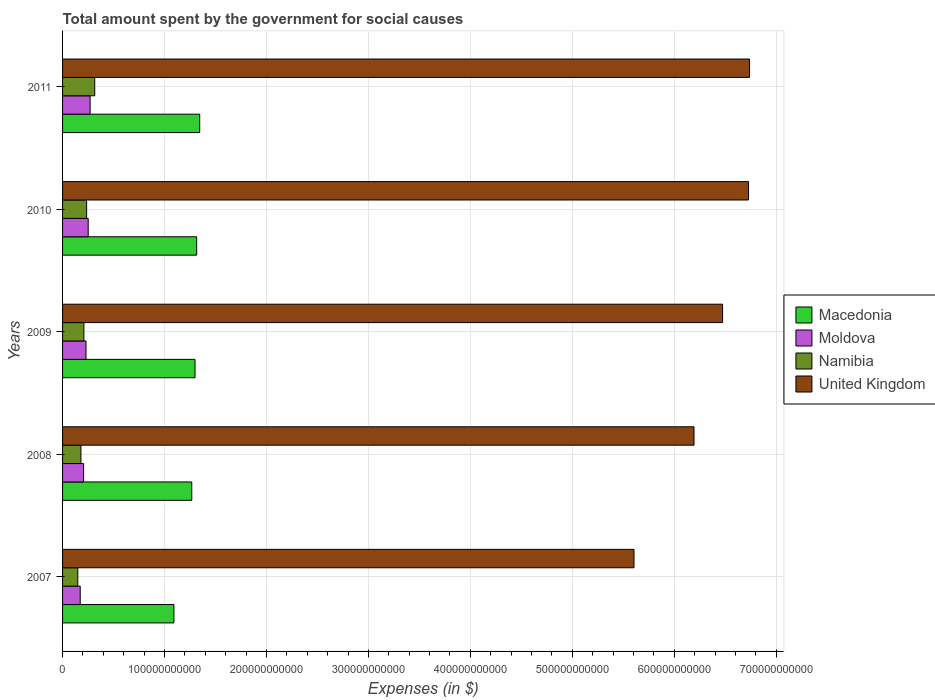How many bars are there on the 4th tick from the top?
Offer a very short reply. 4. How many bars are there on the 2nd tick from the bottom?
Your answer should be compact. 4. What is the label of the 2nd group of bars from the top?
Offer a very short reply. 2010. What is the amount spent for social causes by the government in Namibia in 2010?
Your answer should be very brief. 2.36e+1. Across all years, what is the maximum amount spent for social causes by the government in Namibia?
Give a very brief answer. 3.16e+1. Across all years, what is the minimum amount spent for social causes by the government in Moldova?
Make the answer very short. 1.73e+1. In which year was the amount spent for social causes by the government in Namibia maximum?
Offer a terse response. 2011. What is the total amount spent for social causes by the government in Namibia in the graph?
Your answer should be very brief. 1.09e+11. What is the difference between the amount spent for social causes by the government in Namibia in 2007 and that in 2008?
Provide a short and direct response. -3.08e+09. What is the difference between the amount spent for social causes by the government in Macedonia in 2009 and the amount spent for social causes by the government in United Kingdom in 2008?
Give a very brief answer. -4.89e+11. What is the average amount spent for social causes by the government in Moldova per year?
Provide a short and direct response. 2.26e+1. In the year 2009, what is the difference between the amount spent for social causes by the government in Namibia and amount spent for social causes by the government in United Kingdom?
Your answer should be compact. -6.27e+11. In how many years, is the amount spent for social causes by the government in Moldova greater than 140000000000 $?
Make the answer very short. 0. What is the ratio of the amount spent for social causes by the government in Moldova in 2007 to that in 2008?
Provide a short and direct response. 0.84. Is the difference between the amount spent for social causes by the government in Namibia in 2007 and 2008 greater than the difference between the amount spent for social causes by the government in United Kingdom in 2007 and 2008?
Offer a very short reply. Yes. What is the difference between the highest and the second highest amount spent for social causes by the government in Namibia?
Offer a terse response. 7.94e+09. What is the difference between the highest and the lowest amount spent for social causes by the government in Macedonia?
Ensure brevity in your answer.  2.53e+1. Is the sum of the amount spent for social causes by the government in Moldova in 2008 and 2011 greater than the maximum amount spent for social causes by the government in Macedonia across all years?
Your answer should be compact. No. Is it the case that in every year, the sum of the amount spent for social causes by the government in Macedonia and amount spent for social causes by the government in Namibia is greater than the sum of amount spent for social causes by the government in Moldova and amount spent for social causes by the government in United Kingdom?
Keep it short and to the point. No. What does the 4th bar from the top in 2007 represents?
Your answer should be very brief. Macedonia. What does the 1st bar from the bottom in 2009 represents?
Your answer should be compact. Macedonia. Are all the bars in the graph horizontal?
Ensure brevity in your answer.  Yes. How many years are there in the graph?
Your answer should be very brief. 5. What is the difference between two consecutive major ticks on the X-axis?
Your answer should be compact. 1.00e+11. Are the values on the major ticks of X-axis written in scientific E-notation?
Keep it short and to the point. No. Does the graph contain any zero values?
Your answer should be very brief. No. Does the graph contain grids?
Offer a terse response. Yes. How many legend labels are there?
Your answer should be compact. 4. How are the legend labels stacked?
Give a very brief answer. Vertical. What is the title of the graph?
Ensure brevity in your answer.  Total amount spent by the government for social causes. What is the label or title of the X-axis?
Make the answer very short. Expenses (in $). What is the Expenses (in $) in Macedonia in 2007?
Make the answer very short. 1.09e+11. What is the Expenses (in $) of Moldova in 2007?
Your response must be concise. 1.73e+1. What is the Expenses (in $) in Namibia in 2007?
Keep it short and to the point. 1.49e+1. What is the Expenses (in $) of United Kingdom in 2007?
Provide a succinct answer. 5.61e+11. What is the Expenses (in $) of Macedonia in 2008?
Your answer should be very brief. 1.27e+11. What is the Expenses (in $) of Moldova in 2008?
Your response must be concise. 2.06e+1. What is the Expenses (in $) of Namibia in 2008?
Offer a terse response. 1.80e+1. What is the Expenses (in $) of United Kingdom in 2008?
Keep it short and to the point. 6.19e+11. What is the Expenses (in $) in Macedonia in 2009?
Ensure brevity in your answer.  1.30e+11. What is the Expenses (in $) of Moldova in 2009?
Give a very brief answer. 2.30e+1. What is the Expenses (in $) in Namibia in 2009?
Offer a terse response. 2.09e+1. What is the Expenses (in $) of United Kingdom in 2009?
Your answer should be compact. 6.47e+11. What is the Expenses (in $) of Macedonia in 2010?
Give a very brief answer. 1.32e+11. What is the Expenses (in $) of Moldova in 2010?
Provide a succinct answer. 2.51e+1. What is the Expenses (in $) in Namibia in 2010?
Make the answer very short. 2.36e+1. What is the Expenses (in $) in United Kingdom in 2010?
Your response must be concise. 6.73e+11. What is the Expenses (in $) in Macedonia in 2011?
Your answer should be compact. 1.35e+11. What is the Expenses (in $) in Moldova in 2011?
Keep it short and to the point. 2.70e+1. What is the Expenses (in $) in Namibia in 2011?
Your answer should be compact. 3.16e+1. What is the Expenses (in $) in United Kingdom in 2011?
Keep it short and to the point. 6.74e+11. Across all years, what is the maximum Expenses (in $) of Macedonia?
Keep it short and to the point. 1.35e+11. Across all years, what is the maximum Expenses (in $) in Moldova?
Provide a succinct answer. 2.70e+1. Across all years, what is the maximum Expenses (in $) in Namibia?
Keep it short and to the point. 3.16e+1. Across all years, what is the maximum Expenses (in $) of United Kingdom?
Your answer should be very brief. 6.74e+11. Across all years, what is the minimum Expenses (in $) of Macedonia?
Ensure brevity in your answer.  1.09e+11. Across all years, what is the minimum Expenses (in $) of Moldova?
Your answer should be compact. 1.73e+1. Across all years, what is the minimum Expenses (in $) in Namibia?
Offer a very short reply. 1.49e+1. Across all years, what is the minimum Expenses (in $) of United Kingdom?
Your answer should be compact. 5.61e+11. What is the total Expenses (in $) in Macedonia in the graph?
Your answer should be compact. 6.32e+11. What is the total Expenses (in $) in Moldova in the graph?
Your answer should be very brief. 1.13e+11. What is the total Expenses (in $) of Namibia in the graph?
Ensure brevity in your answer.  1.09e+11. What is the total Expenses (in $) of United Kingdom in the graph?
Keep it short and to the point. 3.17e+12. What is the difference between the Expenses (in $) in Macedonia in 2007 and that in 2008?
Offer a terse response. -1.75e+1. What is the difference between the Expenses (in $) in Moldova in 2007 and that in 2008?
Provide a succinct answer. -3.31e+09. What is the difference between the Expenses (in $) of Namibia in 2007 and that in 2008?
Provide a succinct answer. -3.08e+09. What is the difference between the Expenses (in $) of United Kingdom in 2007 and that in 2008?
Ensure brevity in your answer.  -5.89e+1. What is the difference between the Expenses (in $) of Macedonia in 2007 and that in 2009?
Your answer should be compact. -2.07e+1. What is the difference between the Expenses (in $) of Moldova in 2007 and that in 2009?
Your answer should be compact. -5.67e+09. What is the difference between the Expenses (in $) in Namibia in 2007 and that in 2009?
Provide a short and direct response. -5.99e+09. What is the difference between the Expenses (in $) in United Kingdom in 2007 and that in 2009?
Your answer should be compact. -8.69e+1. What is the difference between the Expenses (in $) in Macedonia in 2007 and that in 2010?
Your response must be concise. -2.23e+1. What is the difference between the Expenses (in $) in Moldova in 2007 and that in 2010?
Provide a short and direct response. -7.83e+09. What is the difference between the Expenses (in $) in Namibia in 2007 and that in 2010?
Keep it short and to the point. -8.67e+09. What is the difference between the Expenses (in $) in United Kingdom in 2007 and that in 2010?
Your answer should be very brief. -1.12e+11. What is the difference between the Expenses (in $) of Macedonia in 2007 and that in 2011?
Make the answer very short. -2.53e+1. What is the difference between the Expenses (in $) of Moldova in 2007 and that in 2011?
Provide a succinct answer. -9.71e+09. What is the difference between the Expenses (in $) in Namibia in 2007 and that in 2011?
Your answer should be very brief. -1.66e+1. What is the difference between the Expenses (in $) in United Kingdom in 2007 and that in 2011?
Provide a succinct answer. -1.13e+11. What is the difference between the Expenses (in $) in Macedonia in 2008 and that in 2009?
Offer a terse response. -3.19e+09. What is the difference between the Expenses (in $) of Moldova in 2008 and that in 2009?
Your answer should be compact. -2.36e+09. What is the difference between the Expenses (in $) in Namibia in 2008 and that in 2009?
Offer a terse response. -2.91e+09. What is the difference between the Expenses (in $) in United Kingdom in 2008 and that in 2009?
Your answer should be very brief. -2.80e+1. What is the difference between the Expenses (in $) in Macedonia in 2008 and that in 2010?
Ensure brevity in your answer.  -4.81e+09. What is the difference between the Expenses (in $) in Moldova in 2008 and that in 2010?
Provide a short and direct response. -4.52e+09. What is the difference between the Expenses (in $) in Namibia in 2008 and that in 2010?
Offer a very short reply. -5.59e+09. What is the difference between the Expenses (in $) of United Kingdom in 2008 and that in 2010?
Your answer should be very brief. -5.35e+1. What is the difference between the Expenses (in $) in Macedonia in 2008 and that in 2011?
Provide a short and direct response. -7.78e+09. What is the difference between the Expenses (in $) of Moldova in 2008 and that in 2011?
Make the answer very short. -6.40e+09. What is the difference between the Expenses (in $) in Namibia in 2008 and that in 2011?
Provide a succinct answer. -1.35e+1. What is the difference between the Expenses (in $) in United Kingdom in 2008 and that in 2011?
Offer a terse response. -5.45e+1. What is the difference between the Expenses (in $) of Macedonia in 2009 and that in 2010?
Keep it short and to the point. -1.62e+09. What is the difference between the Expenses (in $) of Moldova in 2009 and that in 2010?
Your answer should be very brief. -2.16e+09. What is the difference between the Expenses (in $) of Namibia in 2009 and that in 2010?
Ensure brevity in your answer.  -2.68e+09. What is the difference between the Expenses (in $) of United Kingdom in 2009 and that in 2010?
Provide a succinct answer. -2.55e+1. What is the difference between the Expenses (in $) in Macedonia in 2009 and that in 2011?
Ensure brevity in your answer.  -4.59e+09. What is the difference between the Expenses (in $) in Moldova in 2009 and that in 2011?
Keep it short and to the point. -4.04e+09. What is the difference between the Expenses (in $) in Namibia in 2009 and that in 2011?
Keep it short and to the point. -1.06e+1. What is the difference between the Expenses (in $) in United Kingdom in 2009 and that in 2011?
Ensure brevity in your answer.  -2.65e+1. What is the difference between the Expenses (in $) in Macedonia in 2010 and that in 2011?
Your answer should be very brief. -2.96e+09. What is the difference between the Expenses (in $) in Moldova in 2010 and that in 2011?
Give a very brief answer. -1.88e+09. What is the difference between the Expenses (in $) of Namibia in 2010 and that in 2011?
Your response must be concise. -7.94e+09. What is the difference between the Expenses (in $) of United Kingdom in 2010 and that in 2011?
Your answer should be compact. -1.00e+09. What is the difference between the Expenses (in $) in Macedonia in 2007 and the Expenses (in $) in Moldova in 2008?
Your response must be concise. 8.86e+1. What is the difference between the Expenses (in $) of Macedonia in 2007 and the Expenses (in $) of Namibia in 2008?
Your response must be concise. 9.12e+1. What is the difference between the Expenses (in $) in Macedonia in 2007 and the Expenses (in $) in United Kingdom in 2008?
Make the answer very short. -5.10e+11. What is the difference between the Expenses (in $) of Moldova in 2007 and the Expenses (in $) of Namibia in 2008?
Provide a succinct answer. -7.04e+08. What is the difference between the Expenses (in $) in Moldova in 2007 and the Expenses (in $) in United Kingdom in 2008?
Keep it short and to the point. -6.02e+11. What is the difference between the Expenses (in $) of Namibia in 2007 and the Expenses (in $) of United Kingdom in 2008?
Offer a very short reply. -6.04e+11. What is the difference between the Expenses (in $) in Macedonia in 2007 and the Expenses (in $) in Moldova in 2009?
Ensure brevity in your answer.  8.63e+1. What is the difference between the Expenses (in $) of Macedonia in 2007 and the Expenses (in $) of Namibia in 2009?
Offer a terse response. 8.83e+1. What is the difference between the Expenses (in $) in Macedonia in 2007 and the Expenses (in $) in United Kingdom in 2009?
Offer a terse response. -5.38e+11. What is the difference between the Expenses (in $) in Moldova in 2007 and the Expenses (in $) in Namibia in 2009?
Your answer should be very brief. -3.61e+09. What is the difference between the Expenses (in $) in Moldova in 2007 and the Expenses (in $) in United Kingdom in 2009?
Ensure brevity in your answer.  -6.30e+11. What is the difference between the Expenses (in $) of Namibia in 2007 and the Expenses (in $) of United Kingdom in 2009?
Keep it short and to the point. -6.33e+11. What is the difference between the Expenses (in $) of Macedonia in 2007 and the Expenses (in $) of Moldova in 2010?
Your answer should be very brief. 8.41e+1. What is the difference between the Expenses (in $) of Macedonia in 2007 and the Expenses (in $) of Namibia in 2010?
Give a very brief answer. 8.56e+1. What is the difference between the Expenses (in $) of Macedonia in 2007 and the Expenses (in $) of United Kingdom in 2010?
Ensure brevity in your answer.  -5.64e+11. What is the difference between the Expenses (in $) in Moldova in 2007 and the Expenses (in $) in Namibia in 2010?
Offer a terse response. -6.29e+09. What is the difference between the Expenses (in $) of Moldova in 2007 and the Expenses (in $) of United Kingdom in 2010?
Provide a succinct answer. -6.56e+11. What is the difference between the Expenses (in $) of Namibia in 2007 and the Expenses (in $) of United Kingdom in 2010?
Make the answer very short. -6.58e+11. What is the difference between the Expenses (in $) of Macedonia in 2007 and the Expenses (in $) of Moldova in 2011?
Provide a short and direct response. 8.22e+1. What is the difference between the Expenses (in $) of Macedonia in 2007 and the Expenses (in $) of Namibia in 2011?
Provide a short and direct response. 7.77e+1. What is the difference between the Expenses (in $) in Macedonia in 2007 and the Expenses (in $) in United Kingdom in 2011?
Offer a terse response. -5.65e+11. What is the difference between the Expenses (in $) of Moldova in 2007 and the Expenses (in $) of Namibia in 2011?
Offer a terse response. -1.42e+1. What is the difference between the Expenses (in $) of Moldova in 2007 and the Expenses (in $) of United Kingdom in 2011?
Your response must be concise. -6.57e+11. What is the difference between the Expenses (in $) in Namibia in 2007 and the Expenses (in $) in United Kingdom in 2011?
Provide a short and direct response. -6.59e+11. What is the difference between the Expenses (in $) in Macedonia in 2008 and the Expenses (in $) in Moldova in 2009?
Offer a terse response. 1.04e+11. What is the difference between the Expenses (in $) in Macedonia in 2008 and the Expenses (in $) in Namibia in 2009?
Your answer should be compact. 1.06e+11. What is the difference between the Expenses (in $) of Macedonia in 2008 and the Expenses (in $) of United Kingdom in 2009?
Offer a very short reply. -5.21e+11. What is the difference between the Expenses (in $) of Moldova in 2008 and the Expenses (in $) of Namibia in 2009?
Make the answer very short. -3.03e+08. What is the difference between the Expenses (in $) in Moldova in 2008 and the Expenses (in $) in United Kingdom in 2009?
Offer a very short reply. -6.27e+11. What is the difference between the Expenses (in $) of Namibia in 2008 and the Expenses (in $) of United Kingdom in 2009?
Provide a succinct answer. -6.29e+11. What is the difference between the Expenses (in $) of Macedonia in 2008 and the Expenses (in $) of Moldova in 2010?
Ensure brevity in your answer.  1.02e+11. What is the difference between the Expenses (in $) of Macedonia in 2008 and the Expenses (in $) of Namibia in 2010?
Make the answer very short. 1.03e+11. What is the difference between the Expenses (in $) in Macedonia in 2008 and the Expenses (in $) in United Kingdom in 2010?
Keep it short and to the point. -5.46e+11. What is the difference between the Expenses (in $) in Moldova in 2008 and the Expenses (in $) in Namibia in 2010?
Keep it short and to the point. -2.98e+09. What is the difference between the Expenses (in $) in Moldova in 2008 and the Expenses (in $) in United Kingdom in 2010?
Provide a succinct answer. -6.52e+11. What is the difference between the Expenses (in $) of Namibia in 2008 and the Expenses (in $) of United Kingdom in 2010?
Offer a very short reply. -6.55e+11. What is the difference between the Expenses (in $) of Macedonia in 2008 and the Expenses (in $) of Moldova in 2011?
Ensure brevity in your answer.  9.97e+1. What is the difference between the Expenses (in $) of Macedonia in 2008 and the Expenses (in $) of Namibia in 2011?
Offer a terse response. 9.52e+1. What is the difference between the Expenses (in $) in Macedonia in 2008 and the Expenses (in $) in United Kingdom in 2011?
Keep it short and to the point. -5.47e+11. What is the difference between the Expenses (in $) of Moldova in 2008 and the Expenses (in $) of Namibia in 2011?
Give a very brief answer. -1.09e+1. What is the difference between the Expenses (in $) of Moldova in 2008 and the Expenses (in $) of United Kingdom in 2011?
Provide a short and direct response. -6.53e+11. What is the difference between the Expenses (in $) of Namibia in 2008 and the Expenses (in $) of United Kingdom in 2011?
Ensure brevity in your answer.  -6.56e+11. What is the difference between the Expenses (in $) of Macedonia in 2009 and the Expenses (in $) of Moldova in 2010?
Make the answer very short. 1.05e+11. What is the difference between the Expenses (in $) of Macedonia in 2009 and the Expenses (in $) of Namibia in 2010?
Offer a very short reply. 1.06e+11. What is the difference between the Expenses (in $) in Macedonia in 2009 and the Expenses (in $) in United Kingdom in 2010?
Provide a short and direct response. -5.43e+11. What is the difference between the Expenses (in $) of Moldova in 2009 and the Expenses (in $) of Namibia in 2010?
Offer a terse response. -6.19e+08. What is the difference between the Expenses (in $) of Moldova in 2009 and the Expenses (in $) of United Kingdom in 2010?
Give a very brief answer. -6.50e+11. What is the difference between the Expenses (in $) of Namibia in 2009 and the Expenses (in $) of United Kingdom in 2010?
Your response must be concise. -6.52e+11. What is the difference between the Expenses (in $) of Macedonia in 2009 and the Expenses (in $) of Moldova in 2011?
Offer a terse response. 1.03e+11. What is the difference between the Expenses (in $) of Macedonia in 2009 and the Expenses (in $) of Namibia in 2011?
Your answer should be compact. 9.84e+1. What is the difference between the Expenses (in $) in Macedonia in 2009 and the Expenses (in $) in United Kingdom in 2011?
Your response must be concise. -5.44e+11. What is the difference between the Expenses (in $) of Moldova in 2009 and the Expenses (in $) of Namibia in 2011?
Provide a short and direct response. -8.56e+09. What is the difference between the Expenses (in $) in Moldova in 2009 and the Expenses (in $) in United Kingdom in 2011?
Offer a very short reply. -6.51e+11. What is the difference between the Expenses (in $) of Namibia in 2009 and the Expenses (in $) of United Kingdom in 2011?
Make the answer very short. -6.53e+11. What is the difference between the Expenses (in $) of Macedonia in 2010 and the Expenses (in $) of Moldova in 2011?
Ensure brevity in your answer.  1.05e+11. What is the difference between the Expenses (in $) of Macedonia in 2010 and the Expenses (in $) of Namibia in 2011?
Provide a succinct answer. 1.00e+11. What is the difference between the Expenses (in $) in Macedonia in 2010 and the Expenses (in $) in United Kingdom in 2011?
Ensure brevity in your answer.  -5.42e+11. What is the difference between the Expenses (in $) of Moldova in 2010 and the Expenses (in $) of Namibia in 2011?
Your answer should be compact. -6.41e+09. What is the difference between the Expenses (in $) of Moldova in 2010 and the Expenses (in $) of United Kingdom in 2011?
Ensure brevity in your answer.  -6.49e+11. What is the difference between the Expenses (in $) in Namibia in 2010 and the Expenses (in $) in United Kingdom in 2011?
Keep it short and to the point. -6.50e+11. What is the average Expenses (in $) of Macedonia per year?
Ensure brevity in your answer.  1.26e+11. What is the average Expenses (in $) in Moldova per year?
Offer a very short reply. 2.26e+1. What is the average Expenses (in $) in Namibia per year?
Offer a terse response. 2.18e+1. What is the average Expenses (in $) of United Kingdom per year?
Provide a succinct answer. 6.35e+11. In the year 2007, what is the difference between the Expenses (in $) in Macedonia and Expenses (in $) in Moldova?
Offer a very short reply. 9.19e+1. In the year 2007, what is the difference between the Expenses (in $) of Macedonia and Expenses (in $) of Namibia?
Provide a short and direct response. 9.43e+1. In the year 2007, what is the difference between the Expenses (in $) in Macedonia and Expenses (in $) in United Kingdom?
Your answer should be very brief. -4.51e+11. In the year 2007, what is the difference between the Expenses (in $) in Moldova and Expenses (in $) in Namibia?
Your answer should be compact. 2.38e+09. In the year 2007, what is the difference between the Expenses (in $) of Moldova and Expenses (in $) of United Kingdom?
Offer a terse response. -5.43e+11. In the year 2007, what is the difference between the Expenses (in $) in Namibia and Expenses (in $) in United Kingdom?
Offer a very short reply. -5.46e+11. In the year 2008, what is the difference between the Expenses (in $) in Macedonia and Expenses (in $) in Moldova?
Provide a short and direct response. 1.06e+11. In the year 2008, what is the difference between the Expenses (in $) in Macedonia and Expenses (in $) in Namibia?
Your answer should be very brief. 1.09e+11. In the year 2008, what is the difference between the Expenses (in $) in Macedonia and Expenses (in $) in United Kingdom?
Give a very brief answer. -4.93e+11. In the year 2008, what is the difference between the Expenses (in $) of Moldova and Expenses (in $) of Namibia?
Provide a succinct answer. 2.60e+09. In the year 2008, what is the difference between the Expenses (in $) of Moldova and Expenses (in $) of United Kingdom?
Provide a short and direct response. -5.99e+11. In the year 2008, what is the difference between the Expenses (in $) in Namibia and Expenses (in $) in United Kingdom?
Your answer should be compact. -6.01e+11. In the year 2009, what is the difference between the Expenses (in $) of Macedonia and Expenses (in $) of Moldova?
Keep it short and to the point. 1.07e+11. In the year 2009, what is the difference between the Expenses (in $) of Macedonia and Expenses (in $) of Namibia?
Keep it short and to the point. 1.09e+11. In the year 2009, what is the difference between the Expenses (in $) in Macedonia and Expenses (in $) in United Kingdom?
Provide a short and direct response. -5.18e+11. In the year 2009, what is the difference between the Expenses (in $) in Moldova and Expenses (in $) in Namibia?
Offer a terse response. 2.06e+09. In the year 2009, what is the difference between the Expenses (in $) in Moldova and Expenses (in $) in United Kingdom?
Provide a short and direct response. -6.24e+11. In the year 2009, what is the difference between the Expenses (in $) of Namibia and Expenses (in $) of United Kingdom?
Make the answer very short. -6.27e+11. In the year 2010, what is the difference between the Expenses (in $) of Macedonia and Expenses (in $) of Moldova?
Your response must be concise. 1.06e+11. In the year 2010, what is the difference between the Expenses (in $) of Macedonia and Expenses (in $) of Namibia?
Your answer should be very brief. 1.08e+11. In the year 2010, what is the difference between the Expenses (in $) of Macedonia and Expenses (in $) of United Kingdom?
Provide a short and direct response. -5.41e+11. In the year 2010, what is the difference between the Expenses (in $) in Moldova and Expenses (in $) in Namibia?
Your answer should be compact. 1.54e+09. In the year 2010, what is the difference between the Expenses (in $) in Moldova and Expenses (in $) in United Kingdom?
Provide a short and direct response. -6.48e+11. In the year 2010, what is the difference between the Expenses (in $) in Namibia and Expenses (in $) in United Kingdom?
Your answer should be compact. -6.49e+11. In the year 2011, what is the difference between the Expenses (in $) in Macedonia and Expenses (in $) in Moldova?
Ensure brevity in your answer.  1.08e+11. In the year 2011, what is the difference between the Expenses (in $) in Macedonia and Expenses (in $) in Namibia?
Ensure brevity in your answer.  1.03e+11. In the year 2011, what is the difference between the Expenses (in $) of Macedonia and Expenses (in $) of United Kingdom?
Make the answer very short. -5.39e+11. In the year 2011, what is the difference between the Expenses (in $) in Moldova and Expenses (in $) in Namibia?
Your answer should be very brief. -4.53e+09. In the year 2011, what is the difference between the Expenses (in $) of Moldova and Expenses (in $) of United Kingdom?
Your response must be concise. -6.47e+11. In the year 2011, what is the difference between the Expenses (in $) in Namibia and Expenses (in $) in United Kingdom?
Offer a terse response. -6.42e+11. What is the ratio of the Expenses (in $) in Macedonia in 2007 to that in 2008?
Ensure brevity in your answer.  0.86. What is the ratio of the Expenses (in $) of Moldova in 2007 to that in 2008?
Ensure brevity in your answer.  0.84. What is the ratio of the Expenses (in $) in Namibia in 2007 to that in 2008?
Your answer should be very brief. 0.83. What is the ratio of the Expenses (in $) in United Kingdom in 2007 to that in 2008?
Provide a succinct answer. 0.91. What is the ratio of the Expenses (in $) in Macedonia in 2007 to that in 2009?
Make the answer very short. 0.84. What is the ratio of the Expenses (in $) in Moldova in 2007 to that in 2009?
Ensure brevity in your answer.  0.75. What is the ratio of the Expenses (in $) of Namibia in 2007 to that in 2009?
Make the answer very short. 0.71. What is the ratio of the Expenses (in $) in United Kingdom in 2007 to that in 2009?
Your answer should be very brief. 0.87. What is the ratio of the Expenses (in $) of Macedonia in 2007 to that in 2010?
Your answer should be very brief. 0.83. What is the ratio of the Expenses (in $) in Moldova in 2007 to that in 2010?
Make the answer very short. 0.69. What is the ratio of the Expenses (in $) in Namibia in 2007 to that in 2010?
Offer a very short reply. 0.63. What is the ratio of the Expenses (in $) of United Kingdom in 2007 to that in 2010?
Your answer should be very brief. 0.83. What is the ratio of the Expenses (in $) of Macedonia in 2007 to that in 2011?
Give a very brief answer. 0.81. What is the ratio of the Expenses (in $) in Moldova in 2007 to that in 2011?
Your answer should be compact. 0.64. What is the ratio of the Expenses (in $) of Namibia in 2007 to that in 2011?
Your response must be concise. 0.47. What is the ratio of the Expenses (in $) of United Kingdom in 2007 to that in 2011?
Your answer should be very brief. 0.83. What is the ratio of the Expenses (in $) in Macedonia in 2008 to that in 2009?
Ensure brevity in your answer.  0.98. What is the ratio of the Expenses (in $) of Moldova in 2008 to that in 2009?
Ensure brevity in your answer.  0.9. What is the ratio of the Expenses (in $) of Namibia in 2008 to that in 2009?
Provide a succinct answer. 0.86. What is the ratio of the Expenses (in $) of United Kingdom in 2008 to that in 2009?
Provide a short and direct response. 0.96. What is the ratio of the Expenses (in $) of Macedonia in 2008 to that in 2010?
Keep it short and to the point. 0.96. What is the ratio of the Expenses (in $) of Moldova in 2008 to that in 2010?
Your answer should be very brief. 0.82. What is the ratio of the Expenses (in $) of Namibia in 2008 to that in 2010?
Ensure brevity in your answer.  0.76. What is the ratio of the Expenses (in $) of United Kingdom in 2008 to that in 2010?
Offer a very short reply. 0.92. What is the ratio of the Expenses (in $) in Macedonia in 2008 to that in 2011?
Your response must be concise. 0.94. What is the ratio of the Expenses (in $) of Moldova in 2008 to that in 2011?
Provide a short and direct response. 0.76. What is the ratio of the Expenses (in $) of Namibia in 2008 to that in 2011?
Keep it short and to the point. 0.57. What is the ratio of the Expenses (in $) of United Kingdom in 2008 to that in 2011?
Provide a short and direct response. 0.92. What is the ratio of the Expenses (in $) of Macedonia in 2009 to that in 2010?
Your answer should be very brief. 0.99. What is the ratio of the Expenses (in $) of Moldova in 2009 to that in 2010?
Your answer should be very brief. 0.91. What is the ratio of the Expenses (in $) of Namibia in 2009 to that in 2010?
Your answer should be compact. 0.89. What is the ratio of the Expenses (in $) in United Kingdom in 2009 to that in 2010?
Provide a succinct answer. 0.96. What is the ratio of the Expenses (in $) of Macedonia in 2009 to that in 2011?
Your answer should be very brief. 0.97. What is the ratio of the Expenses (in $) in Moldova in 2009 to that in 2011?
Provide a short and direct response. 0.85. What is the ratio of the Expenses (in $) in Namibia in 2009 to that in 2011?
Keep it short and to the point. 0.66. What is the ratio of the Expenses (in $) of United Kingdom in 2009 to that in 2011?
Make the answer very short. 0.96. What is the ratio of the Expenses (in $) in Moldova in 2010 to that in 2011?
Your answer should be very brief. 0.93. What is the ratio of the Expenses (in $) in Namibia in 2010 to that in 2011?
Provide a short and direct response. 0.75. What is the difference between the highest and the second highest Expenses (in $) of Macedonia?
Your answer should be very brief. 2.96e+09. What is the difference between the highest and the second highest Expenses (in $) of Moldova?
Provide a short and direct response. 1.88e+09. What is the difference between the highest and the second highest Expenses (in $) of Namibia?
Offer a very short reply. 7.94e+09. What is the difference between the highest and the second highest Expenses (in $) of United Kingdom?
Offer a very short reply. 1.00e+09. What is the difference between the highest and the lowest Expenses (in $) in Macedonia?
Your response must be concise. 2.53e+1. What is the difference between the highest and the lowest Expenses (in $) in Moldova?
Make the answer very short. 9.71e+09. What is the difference between the highest and the lowest Expenses (in $) of Namibia?
Your answer should be very brief. 1.66e+1. What is the difference between the highest and the lowest Expenses (in $) of United Kingdom?
Offer a terse response. 1.13e+11. 